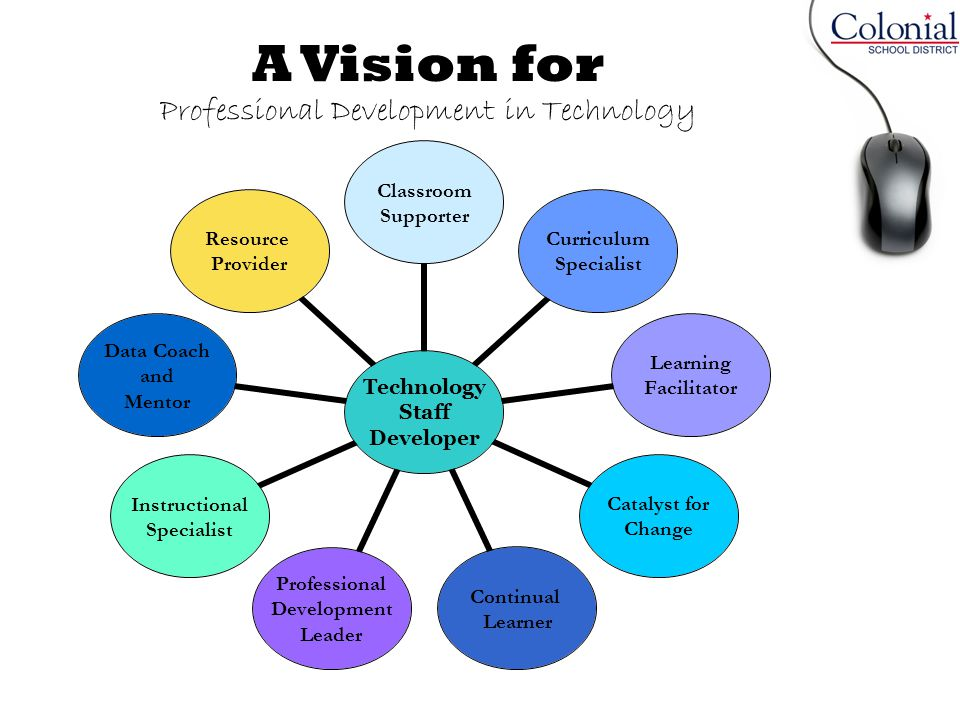What could be a realistic scenario involving the 'Instructional Specialist' role within this vision for professional development in technology? A realistic scenario involving the 'Instructional Specialist' might entail collaborating with classroom teachers to design tech-enabled lesson plans that align with the curriculum standards. For example, the Instructional Specialist could work with a middle school science teacher to integrate an online platform that simulates physical phenomena. The specialist would provide training on how to use the platform effectively, demonstrating how to set up simulations and interpret the results with students. They might also offer ongoing support and guidance, helping teachers troubleshoot any issues and continuously refine their instructional strategies to maximize the impact of the technology on student learning. Could you outline a brief scenario showing the impact of this collaboration on students' learning experience? In this scenario, students would be able to experiment with virtual simulations of scientific concepts, such as the principles of electromagnetism, that would be too dangerous or impractical to demonstrate in a traditional classroom setting. Through these simulations, they can visualize and manipulate variables to see real-time results of their experiments. This hands-on approach allows them to develop a deeper understanding of the subject matter, leading to improved engagement and retention. The instructional support ensures that the teacher can confidently guide the students through these complex concepts, facilitating a more dynamic and interactive learning experience. As a result, students are more likely to develop critical thinking and problem-solving skills, preparing them for future academic and professional pursuits. 